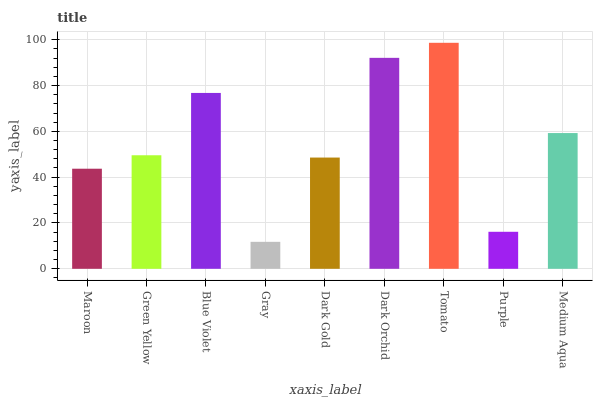Is Gray the minimum?
Answer yes or no. Yes. Is Tomato the maximum?
Answer yes or no. Yes. Is Green Yellow the minimum?
Answer yes or no. No. Is Green Yellow the maximum?
Answer yes or no. No. Is Green Yellow greater than Maroon?
Answer yes or no. Yes. Is Maroon less than Green Yellow?
Answer yes or no. Yes. Is Maroon greater than Green Yellow?
Answer yes or no. No. Is Green Yellow less than Maroon?
Answer yes or no. No. Is Green Yellow the high median?
Answer yes or no. Yes. Is Green Yellow the low median?
Answer yes or no. Yes. Is Blue Violet the high median?
Answer yes or no. No. Is Medium Aqua the low median?
Answer yes or no. No. 